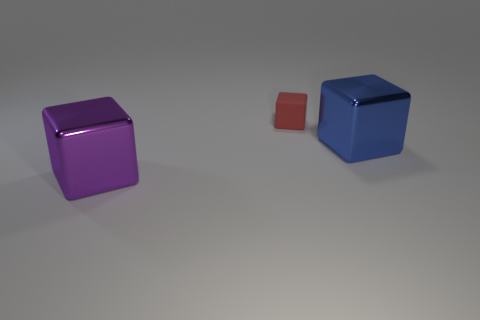Subtract all large metal blocks. How many blocks are left? 1 Add 1 red rubber cubes. How many objects exist? 4 Subtract all green cubes. Subtract all blue cylinders. How many cubes are left? 3 Subtract all tiny red objects. Subtract all purple things. How many objects are left? 1 Add 3 purple metallic cubes. How many purple metallic cubes are left? 4 Add 2 blue shiny objects. How many blue shiny objects exist? 3 Subtract 0 red balls. How many objects are left? 3 